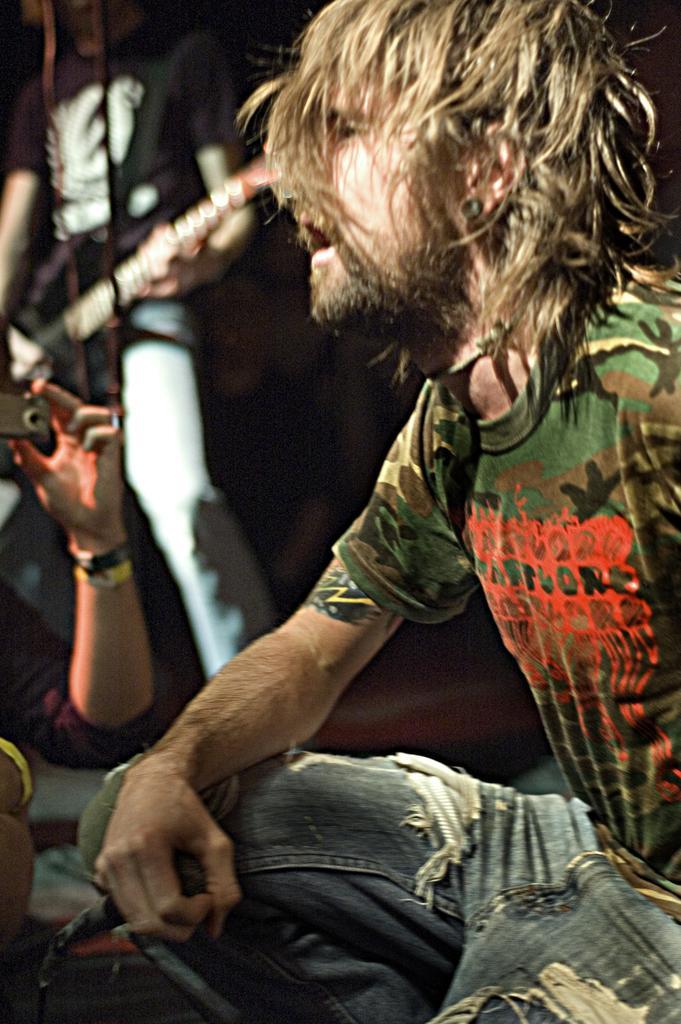Can you describe this image briefly? To the right side of the image there is a man with green t-shirt and jeans is in sitting position and holding the mic in his hand. And to the left side of the image there is a man with black t-shirt is standing and playing guitar. To the bottom left of the image there is a person hand holding the camera in the hand. 